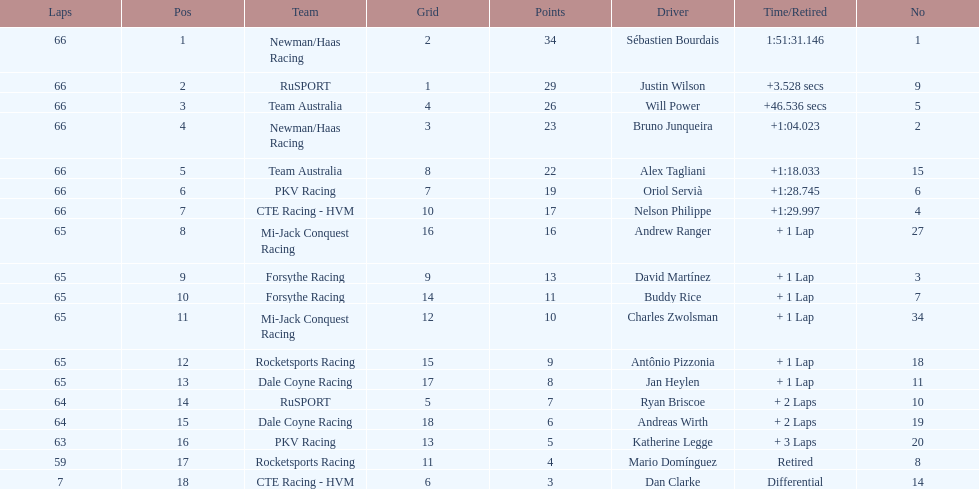At the 2006 gran premio telmex, how many drivers completed less than 60 laps? 2. 